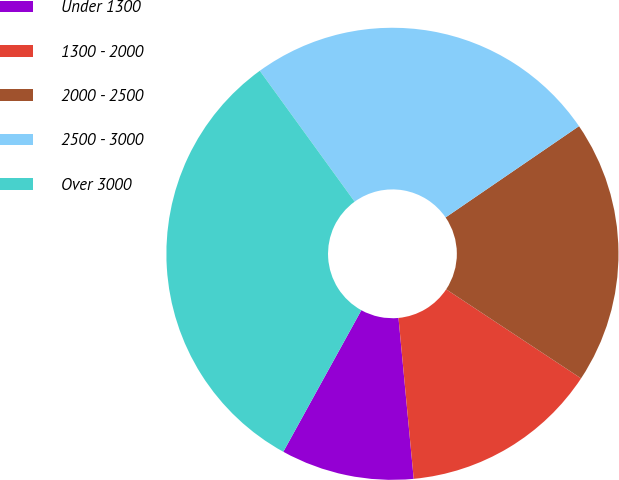Convert chart. <chart><loc_0><loc_0><loc_500><loc_500><pie_chart><fcel>Under 1300<fcel>1300 - 2000<fcel>2000 - 2500<fcel>2500 - 3000<fcel>Over 3000<nl><fcel>9.52%<fcel>14.21%<fcel>18.84%<fcel>25.43%<fcel>32.0%<nl></chart> 